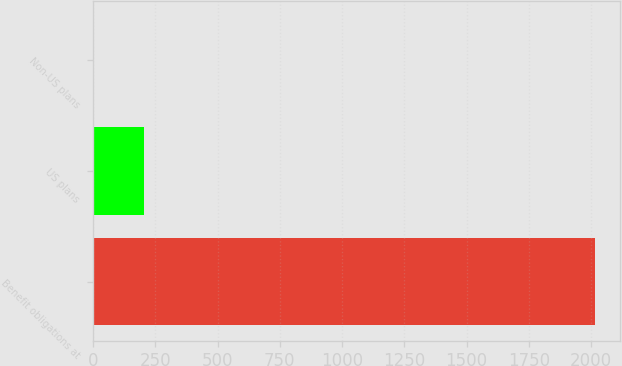<chart> <loc_0><loc_0><loc_500><loc_500><bar_chart><fcel>Benefit obligations at<fcel>US plans<fcel>Non-US plans<nl><fcel>2016<fcel>203.94<fcel>2.6<nl></chart> 